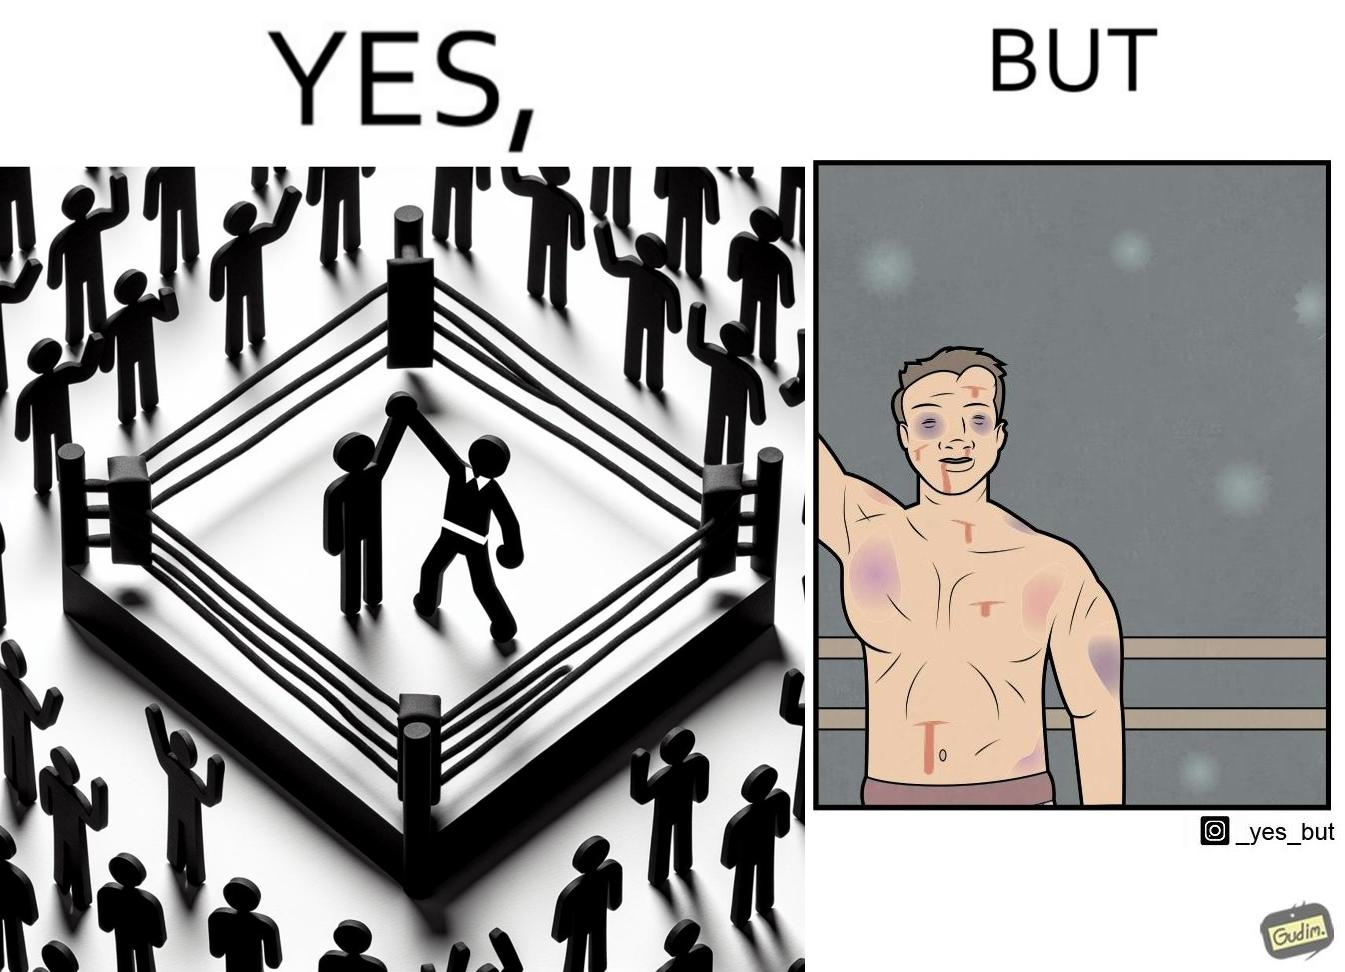Describe what you see in this image. The image is ironic because even though a boxer has won the match and it is supposed to be a moment of celebration, the boxer got bruised in several places during the match. This is an illustration of what hurdles a person has to go through in order to succeed. 